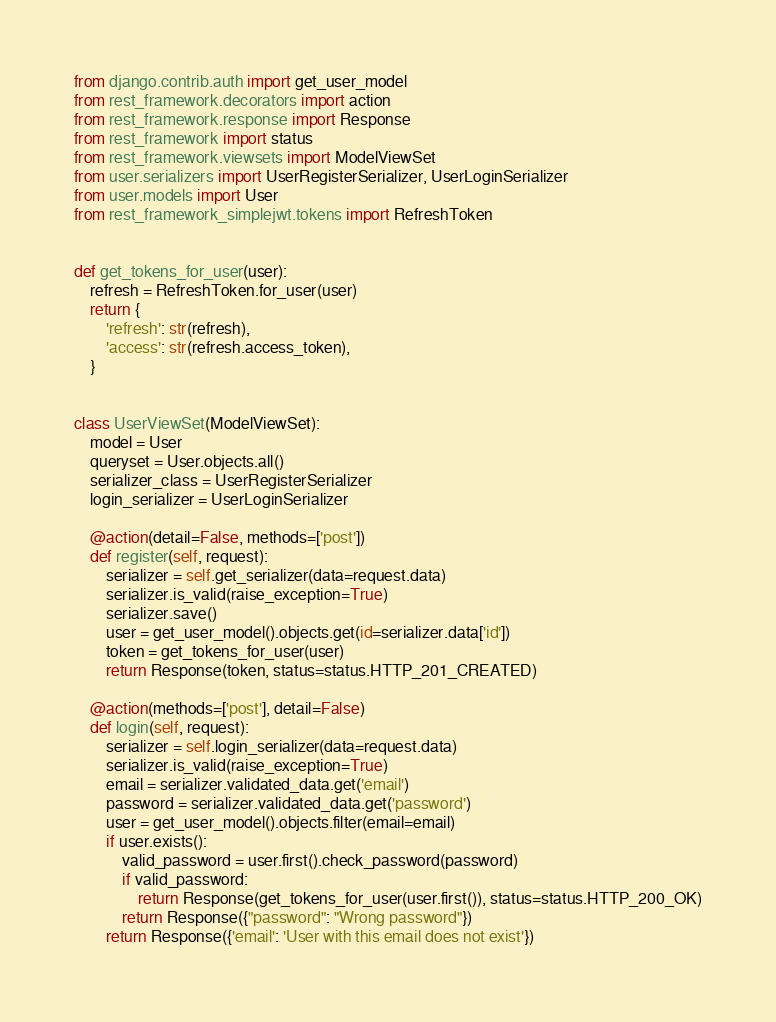Convert code to text. <code><loc_0><loc_0><loc_500><loc_500><_Python_>from django.contrib.auth import get_user_model
from rest_framework.decorators import action
from rest_framework.response import Response
from rest_framework import status
from rest_framework.viewsets import ModelViewSet
from user.serializers import UserRegisterSerializer, UserLoginSerializer
from user.models import User
from rest_framework_simplejwt.tokens import RefreshToken


def get_tokens_for_user(user):
    refresh = RefreshToken.for_user(user)
    return {
        'refresh': str(refresh),
        'access': str(refresh.access_token),
    }


class UserViewSet(ModelViewSet):
    model = User
    queryset = User.objects.all()
    serializer_class = UserRegisterSerializer
    login_serializer = UserLoginSerializer

    @action(detail=False, methods=['post'])
    def register(self, request):
        serializer = self.get_serializer(data=request.data)
        serializer.is_valid(raise_exception=True)
        serializer.save()
        user = get_user_model().objects.get(id=serializer.data['id'])
        token = get_tokens_for_user(user)
        return Response(token, status=status.HTTP_201_CREATED)

    @action(methods=['post'], detail=False)
    def login(self, request):
        serializer = self.login_serializer(data=request.data)
        serializer.is_valid(raise_exception=True)
        email = serializer.validated_data.get('email')
        password = serializer.validated_data.get('password')
        user = get_user_model().objects.filter(email=email)
        if user.exists():
            valid_password = user.first().check_password(password)
            if valid_password:
                return Response(get_tokens_for_user(user.first()), status=status.HTTP_200_OK)
            return Response({"password": "Wrong password"})
        return Response({'email': 'User with this email does not exist'})
</code> 